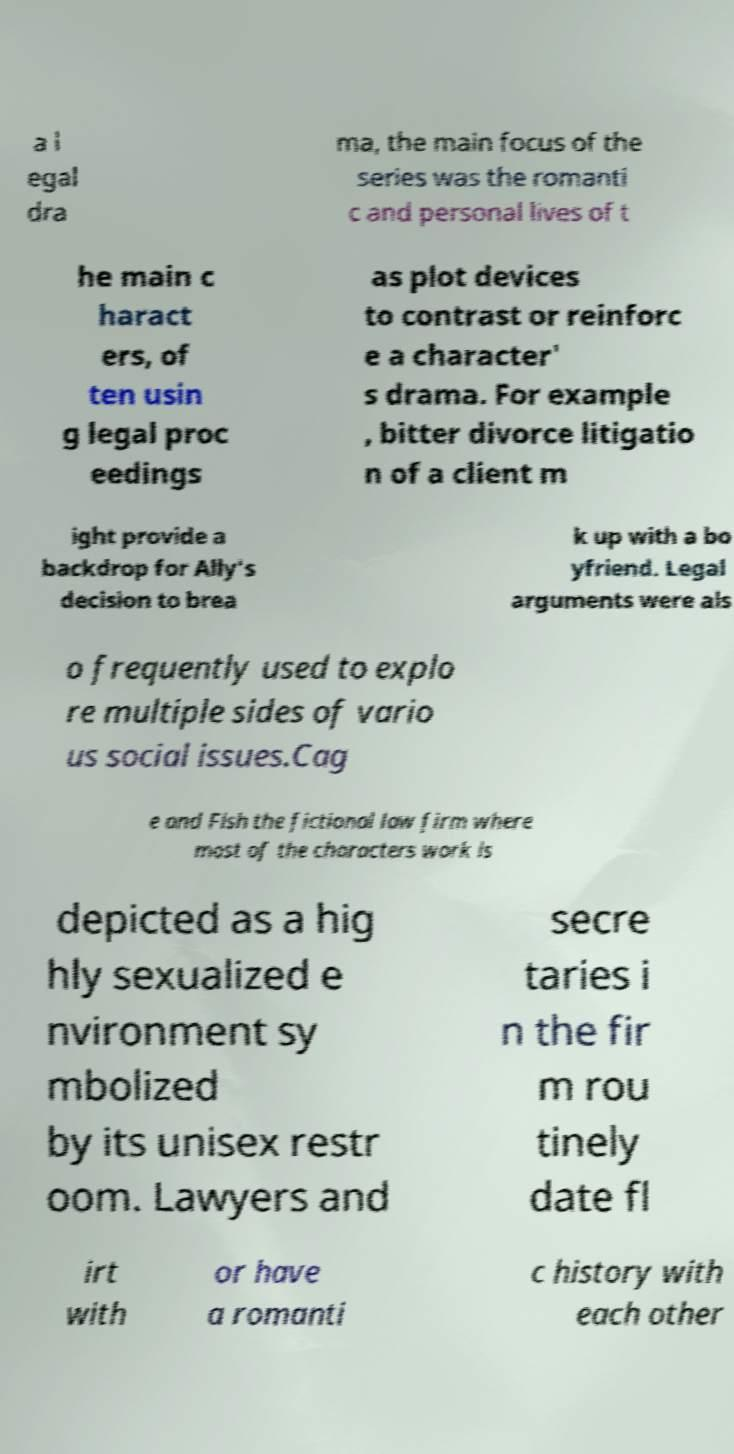Could you extract and type out the text from this image? a l egal dra ma, the main focus of the series was the romanti c and personal lives of t he main c haract ers, of ten usin g legal proc eedings as plot devices to contrast or reinforc e a character' s drama. For example , bitter divorce litigatio n of a client m ight provide a backdrop for Ally's decision to brea k up with a bo yfriend. Legal arguments were als o frequently used to explo re multiple sides of vario us social issues.Cag e and Fish the fictional law firm where most of the characters work is depicted as a hig hly sexualized e nvironment sy mbolized by its unisex restr oom. Lawyers and secre taries i n the fir m rou tinely date fl irt with or have a romanti c history with each other 